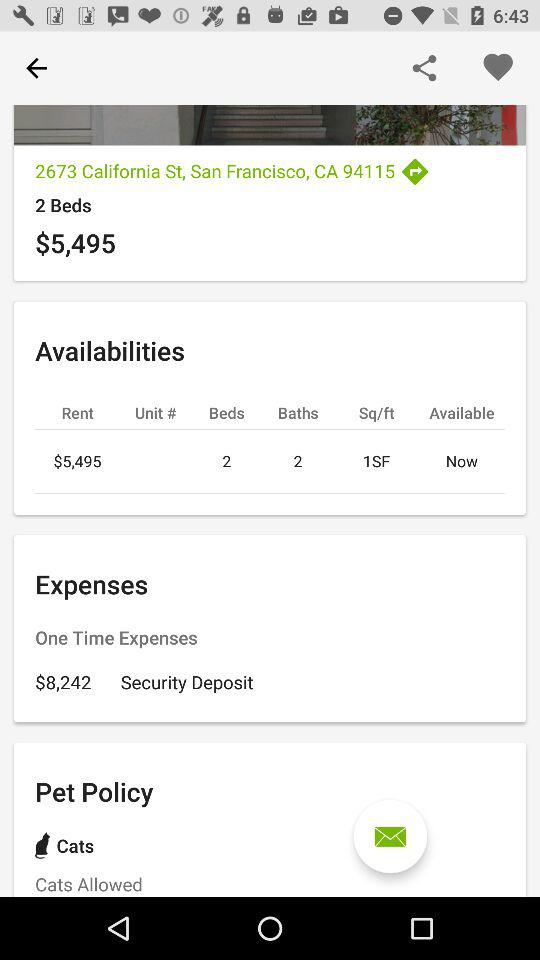How many square feet are available? There is 1 square foot available. 